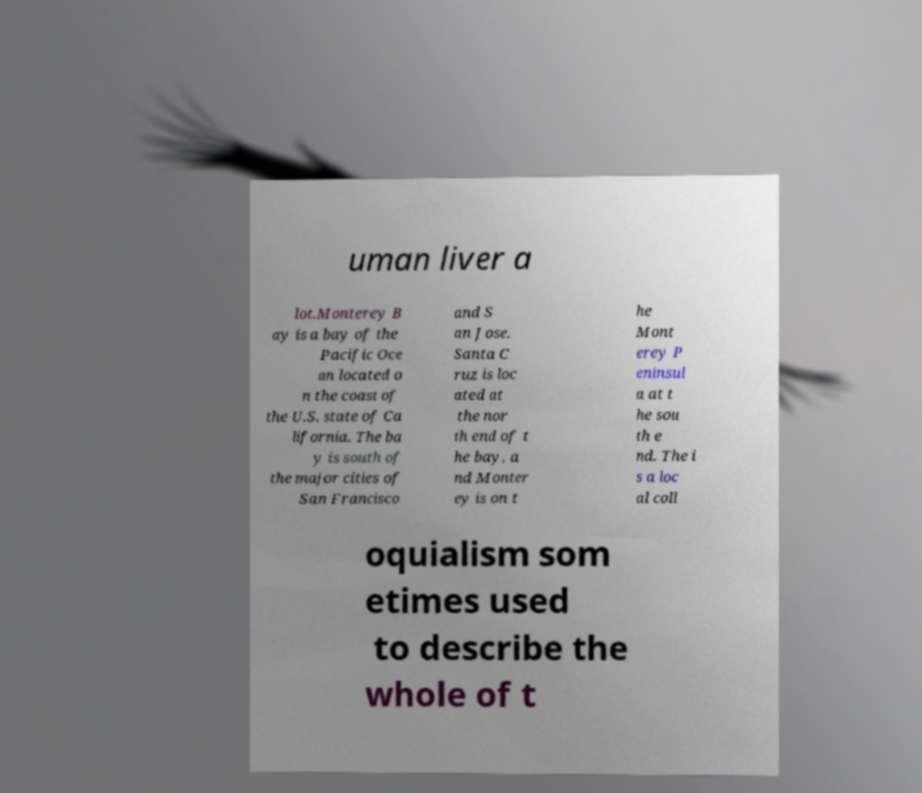Can you read and provide the text displayed in the image?This photo seems to have some interesting text. Can you extract and type it out for me? uman liver a lot.Monterey B ay is a bay of the Pacific Oce an located o n the coast of the U.S. state of Ca lifornia. The ba y is south of the major cities of San Francisco and S an Jose. Santa C ruz is loc ated at the nor th end of t he bay, a nd Monter ey is on t he Mont erey P eninsul a at t he sou th e nd. The i s a loc al coll oquialism som etimes used to describe the whole of t 